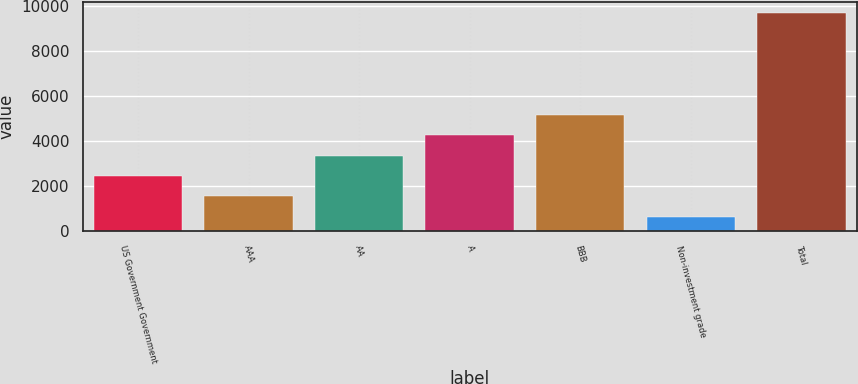<chart> <loc_0><loc_0><loc_500><loc_500><bar_chart><fcel>US Government Government<fcel>AAA<fcel>AA<fcel>A<fcel>BBB<fcel>Non-investment grade<fcel>Total<nl><fcel>2461<fcel>1554.5<fcel>3367.5<fcel>4274<fcel>5180.5<fcel>648<fcel>9713<nl></chart> 